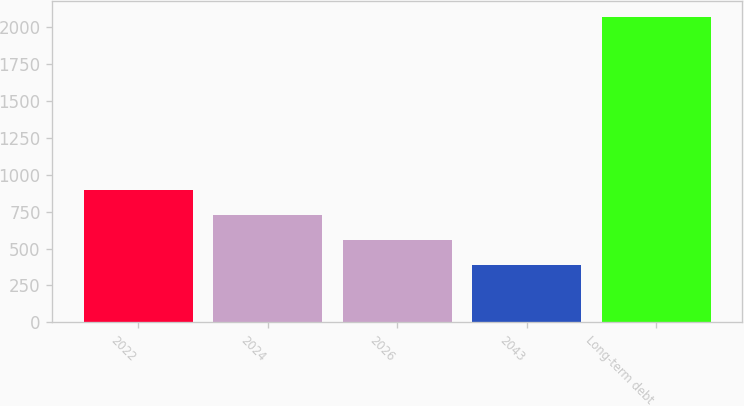Convert chart. <chart><loc_0><loc_0><loc_500><loc_500><bar_chart><fcel>2022<fcel>2024<fcel>2026<fcel>2043<fcel>Long-term debt<nl><fcel>894.7<fcel>726.4<fcel>558.1<fcel>389.8<fcel>2072.8<nl></chart> 